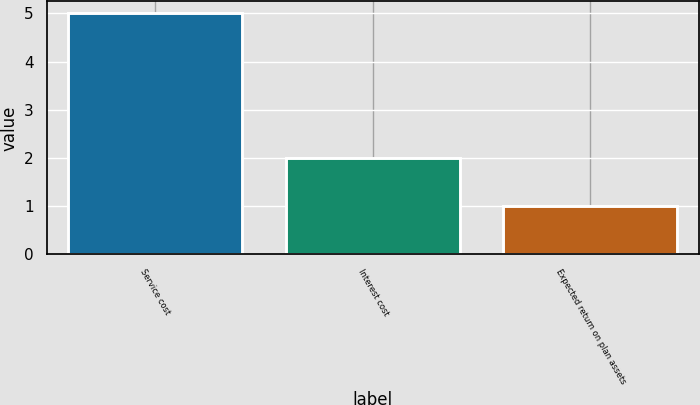Convert chart to OTSL. <chart><loc_0><loc_0><loc_500><loc_500><bar_chart><fcel>Service cost<fcel>Interest cost<fcel>Expected return on plan assets<nl><fcel>5<fcel>2<fcel>1<nl></chart> 